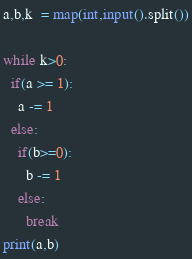Convert code to text. <code><loc_0><loc_0><loc_500><loc_500><_Python_>a,b,k  = map(int,input().split())

while k>0:
  if(a >= 1):
    a -= 1
  else:
    if(b>=0):
      b -= 1
    else:
      break
print(a,b)</code> 